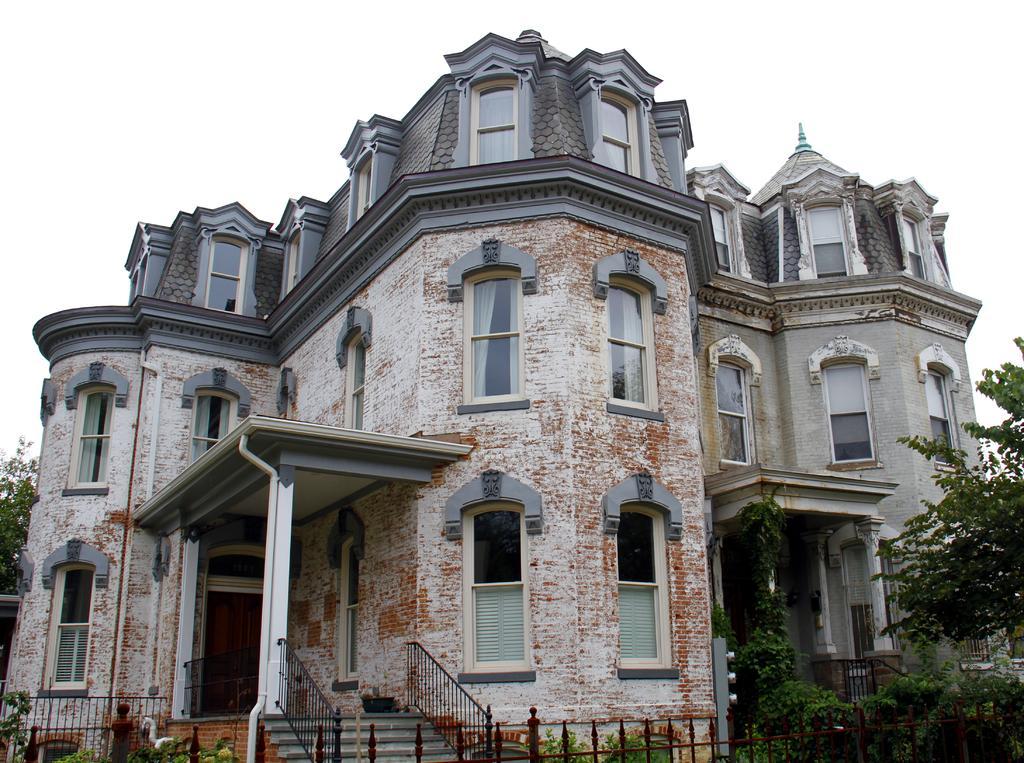Could you give a brief overview of what you see in this image? In this picture we can see a building with windows, pillars, steps, fence, trees and in the background we can see the sky. 